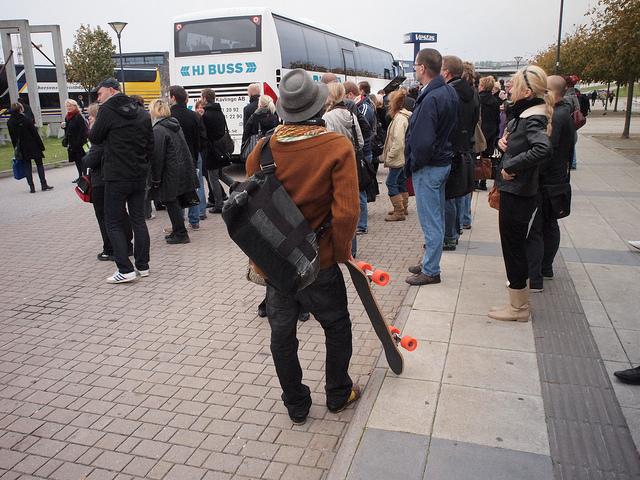Is there a lamp post?
Give a very brief answer. Yes. What color is the bus?
Answer briefly. White. What color are the wheels on the skateboard?
Keep it brief. Orange. 